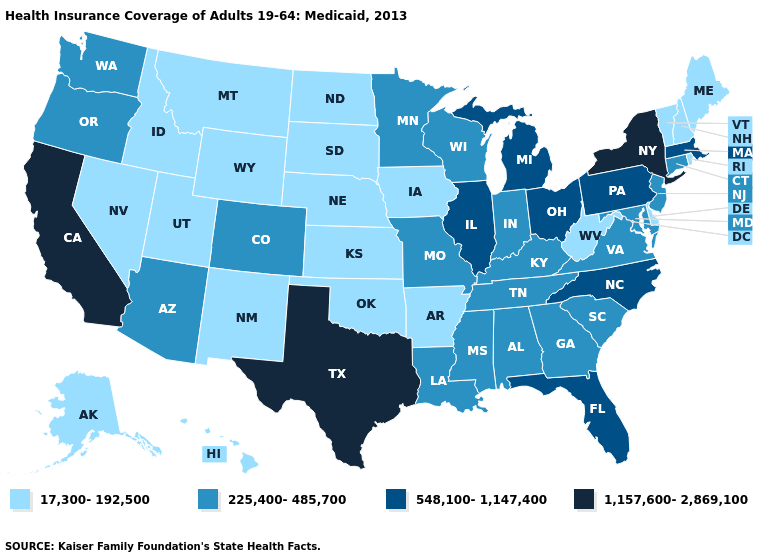What is the value of Maryland?
Concise answer only. 225,400-485,700. Does the first symbol in the legend represent the smallest category?
Write a very short answer. Yes. Among the states that border Oklahoma , does Colorado have the lowest value?
Short answer required. No. Name the states that have a value in the range 17,300-192,500?
Answer briefly. Alaska, Arkansas, Delaware, Hawaii, Idaho, Iowa, Kansas, Maine, Montana, Nebraska, Nevada, New Hampshire, New Mexico, North Dakota, Oklahoma, Rhode Island, South Dakota, Utah, Vermont, West Virginia, Wyoming. Which states have the lowest value in the USA?
Be succinct. Alaska, Arkansas, Delaware, Hawaii, Idaho, Iowa, Kansas, Maine, Montana, Nebraska, Nevada, New Hampshire, New Mexico, North Dakota, Oklahoma, Rhode Island, South Dakota, Utah, Vermont, West Virginia, Wyoming. What is the value of Florida?
Be succinct. 548,100-1,147,400. Name the states that have a value in the range 548,100-1,147,400?
Write a very short answer. Florida, Illinois, Massachusetts, Michigan, North Carolina, Ohio, Pennsylvania. Among the states that border Mississippi , which have the lowest value?
Short answer required. Arkansas. Does California have the highest value in the USA?
Be succinct. Yes. Name the states that have a value in the range 17,300-192,500?
Give a very brief answer. Alaska, Arkansas, Delaware, Hawaii, Idaho, Iowa, Kansas, Maine, Montana, Nebraska, Nevada, New Hampshire, New Mexico, North Dakota, Oklahoma, Rhode Island, South Dakota, Utah, Vermont, West Virginia, Wyoming. Name the states that have a value in the range 225,400-485,700?
Write a very short answer. Alabama, Arizona, Colorado, Connecticut, Georgia, Indiana, Kentucky, Louisiana, Maryland, Minnesota, Mississippi, Missouri, New Jersey, Oregon, South Carolina, Tennessee, Virginia, Washington, Wisconsin. What is the lowest value in the South?
Concise answer only. 17,300-192,500. Among the states that border Pennsylvania , which have the lowest value?
Give a very brief answer. Delaware, West Virginia. What is the highest value in the USA?
Be succinct. 1,157,600-2,869,100. Name the states that have a value in the range 1,157,600-2,869,100?
Concise answer only. California, New York, Texas. 